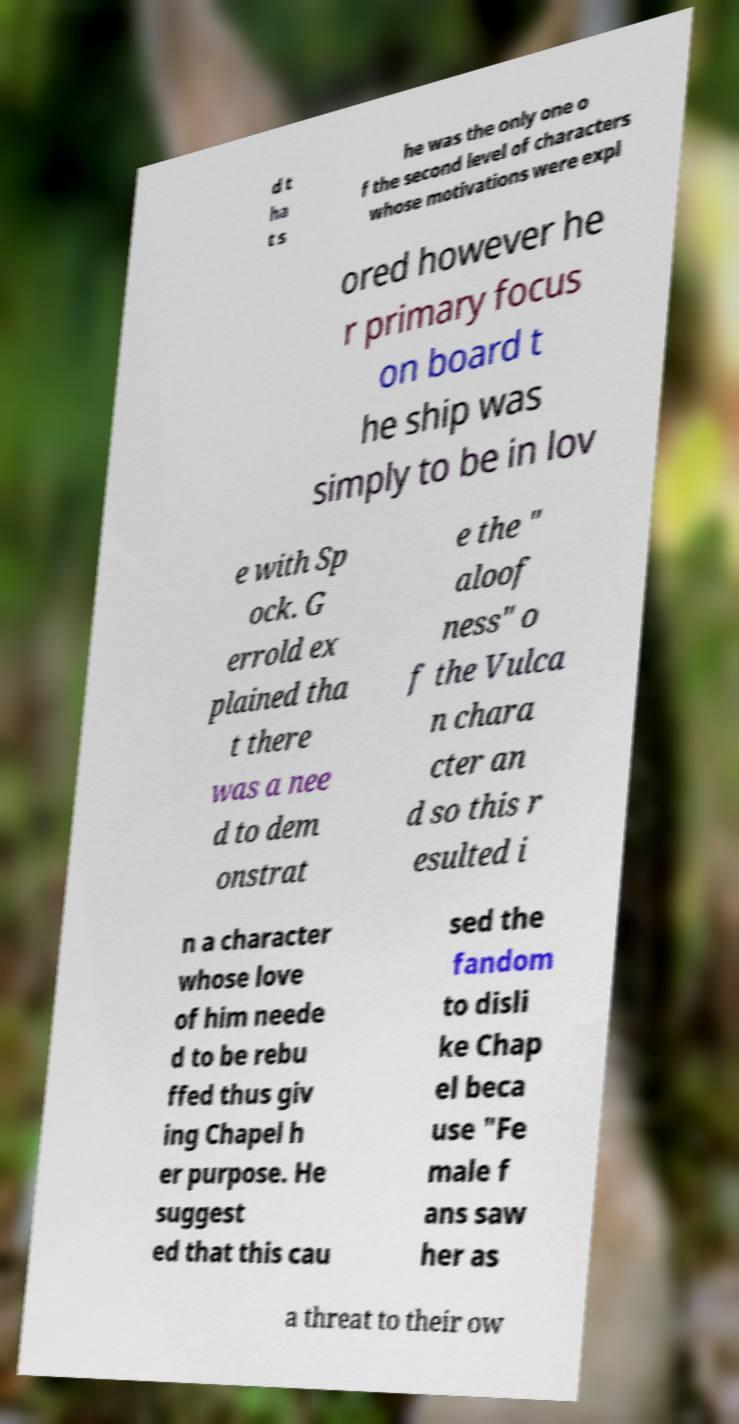Could you assist in decoding the text presented in this image and type it out clearly? d t ha t s he was the only one o f the second level of characters whose motivations were expl ored however he r primary focus on board t he ship was simply to be in lov e with Sp ock. G errold ex plained tha t there was a nee d to dem onstrat e the " aloof ness" o f the Vulca n chara cter an d so this r esulted i n a character whose love of him neede d to be rebu ffed thus giv ing Chapel h er purpose. He suggest ed that this cau sed the fandom to disli ke Chap el beca use "Fe male f ans saw her as a threat to their ow 